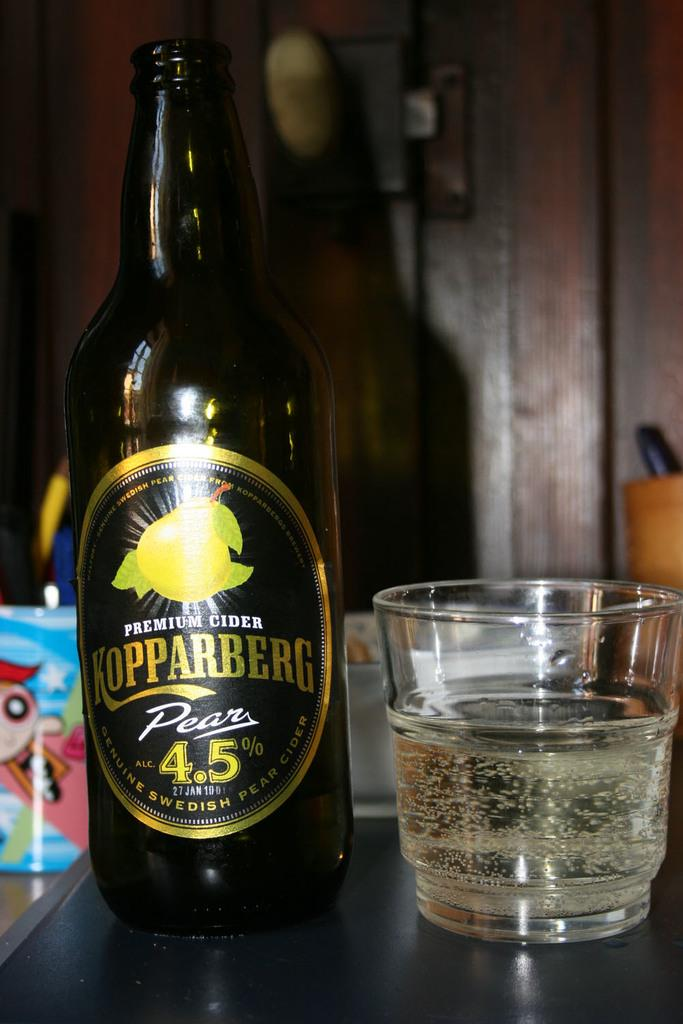<image>
Give a short and clear explanation of the subsequent image. A bottle of premium cider and a glass are sitting on a table. 